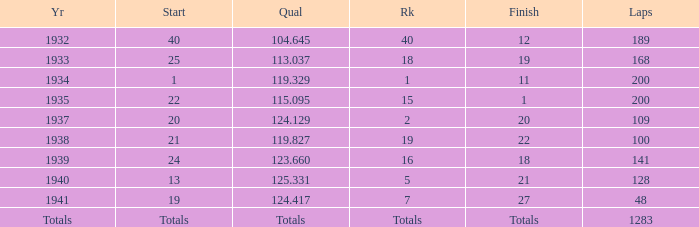What year did he start at 13? 1940.0. 